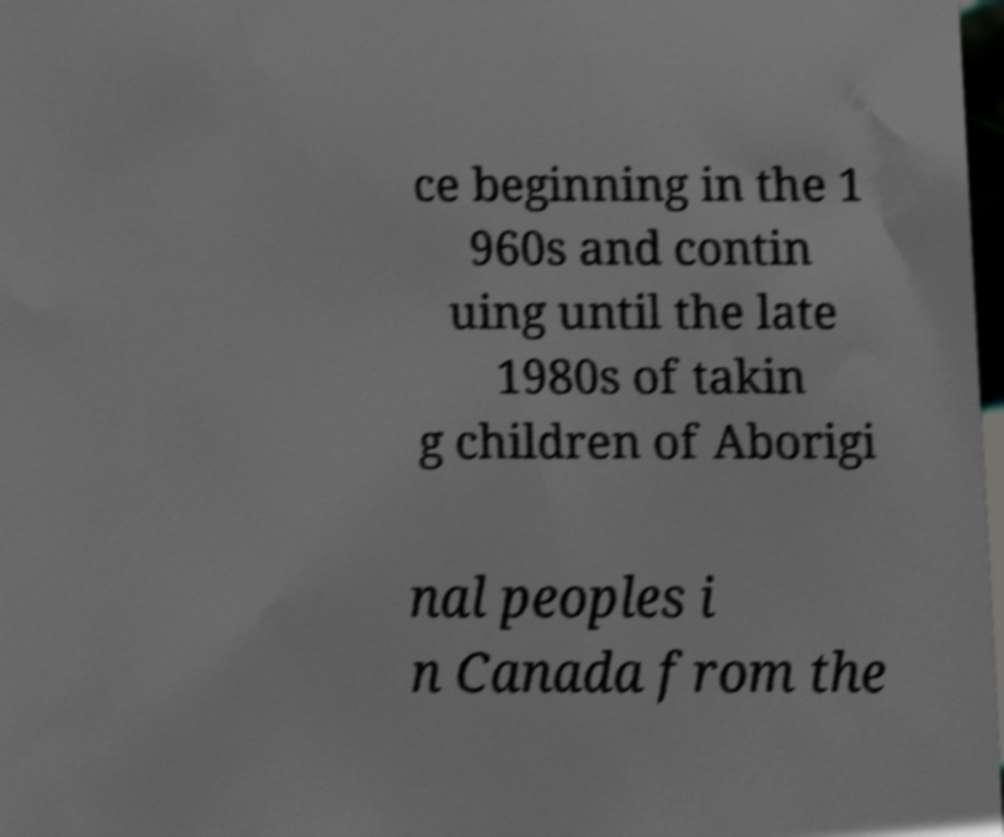I need the written content from this picture converted into text. Can you do that? ce beginning in the 1 960s and contin uing until the late 1980s of takin g children of Aborigi nal peoples i n Canada from the 